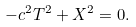Convert formula to latex. <formula><loc_0><loc_0><loc_500><loc_500>- c ^ { 2 } T ^ { 2 } + X ^ { 2 } = 0 .</formula> 